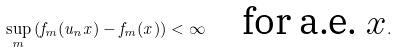<formula> <loc_0><loc_0><loc_500><loc_500>\sup _ { m } \left ( f _ { m } ( u _ { n } x ) - f _ { m } ( x ) \right ) < \infty \quad \text {for a.e. $x$} .</formula> 